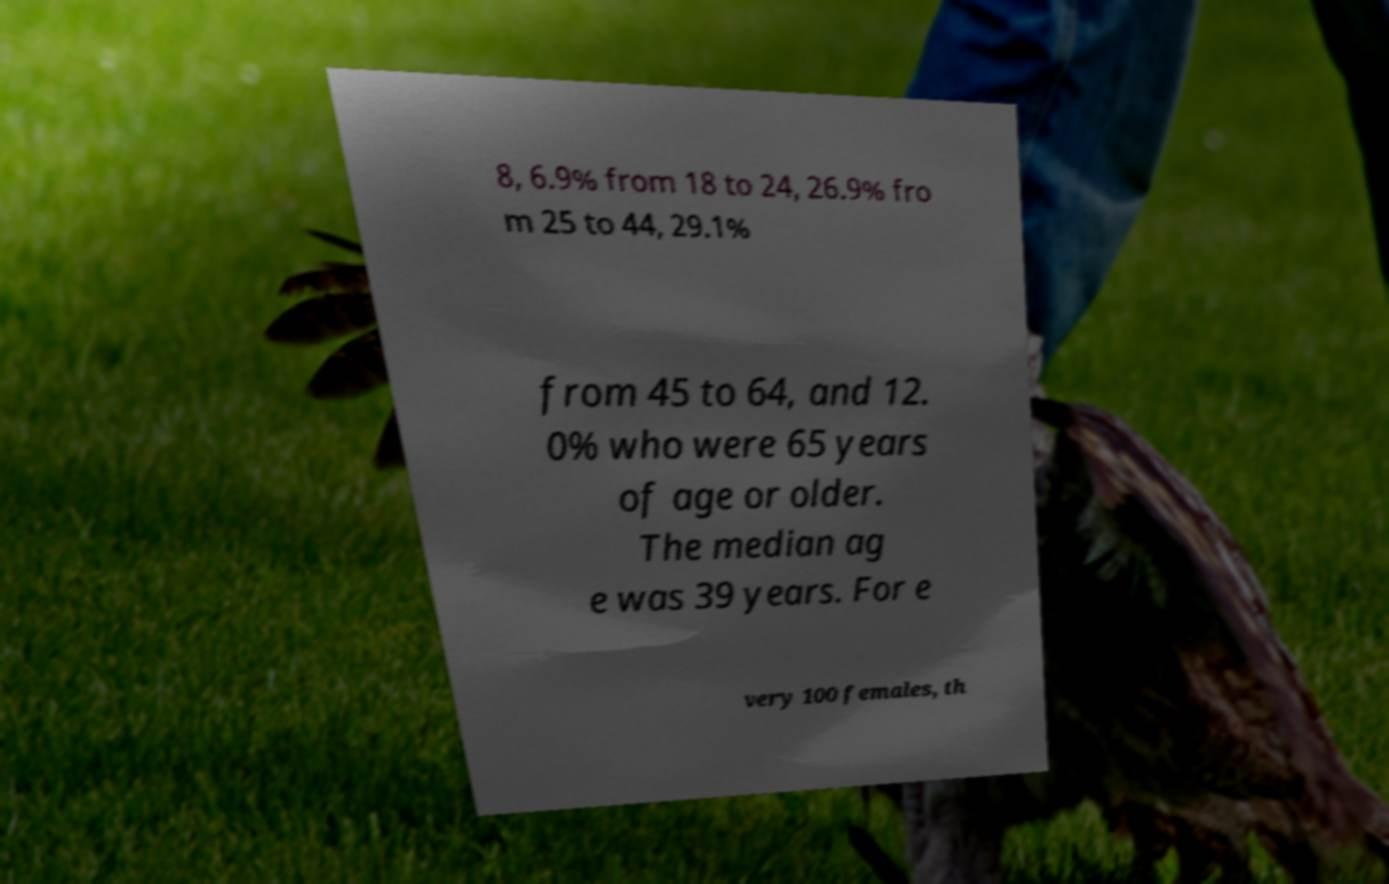Could you assist in decoding the text presented in this image and type it out clearly? 8, 6.9% from 18 to 24, 26.9% fro m 25 to 44, 29.1% from 45 to 64, and 12. 0% who were 65 years of age or older. The median ag e was 39 years. For e very 100 females, th 